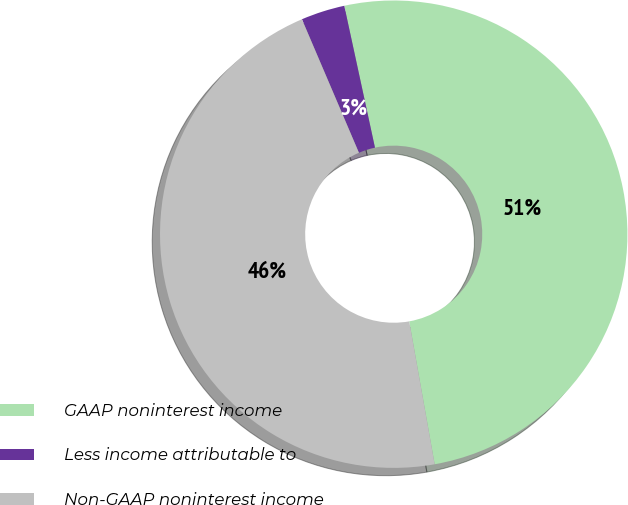<chart> <loc_0><loc_0><loc_500><loc_500><pie_chart><fcel>GAAP noninterest income<fcel>Less income attributable to<fcel>Non-GAAP noninterest income<nl><fcel>50.59%<fcel>3.03%<fcel>46.38%<nl></chart> 